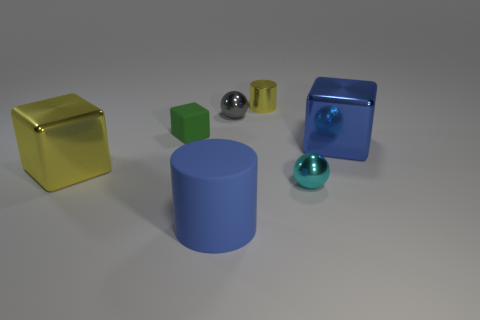How many yellow things are made of the same material as the small cyan ball?
Provide a short and direct response. 2. There is a cylinder that is the same material as the tiny cyan object; what is its color?
Your answer should be very brief. Yellow. There is a small sphere to the right of the tiny metal cylinder; is its color the same as the matte cube?
Your answer should be compact. No. There is a large blue object that is on the left side of the cyan sphere; what material is it?
Ensure brevity in your answer.  Rubber. Are there an equal number of small cubes right of the blue metal thing and tiny blue matte cylinders?
Ensure brevity in your answer.  Yes. What number of matte blocks have the same color as the small matte thing?
Offer a very short reply. 0. The other object that is the same shape as the big matte thing is what color?
Give a very brief answer. Yellow. Does the rubber cube have the same size as the blue block?
Offer a very short reply. No. Are there the same number of tiny spheres behind the green rubber block and large blue metallic things that are left of the gray sphere?
Keep it short and to the point. No. Are any red cubes visible?
Provide a succinct answer. No. 